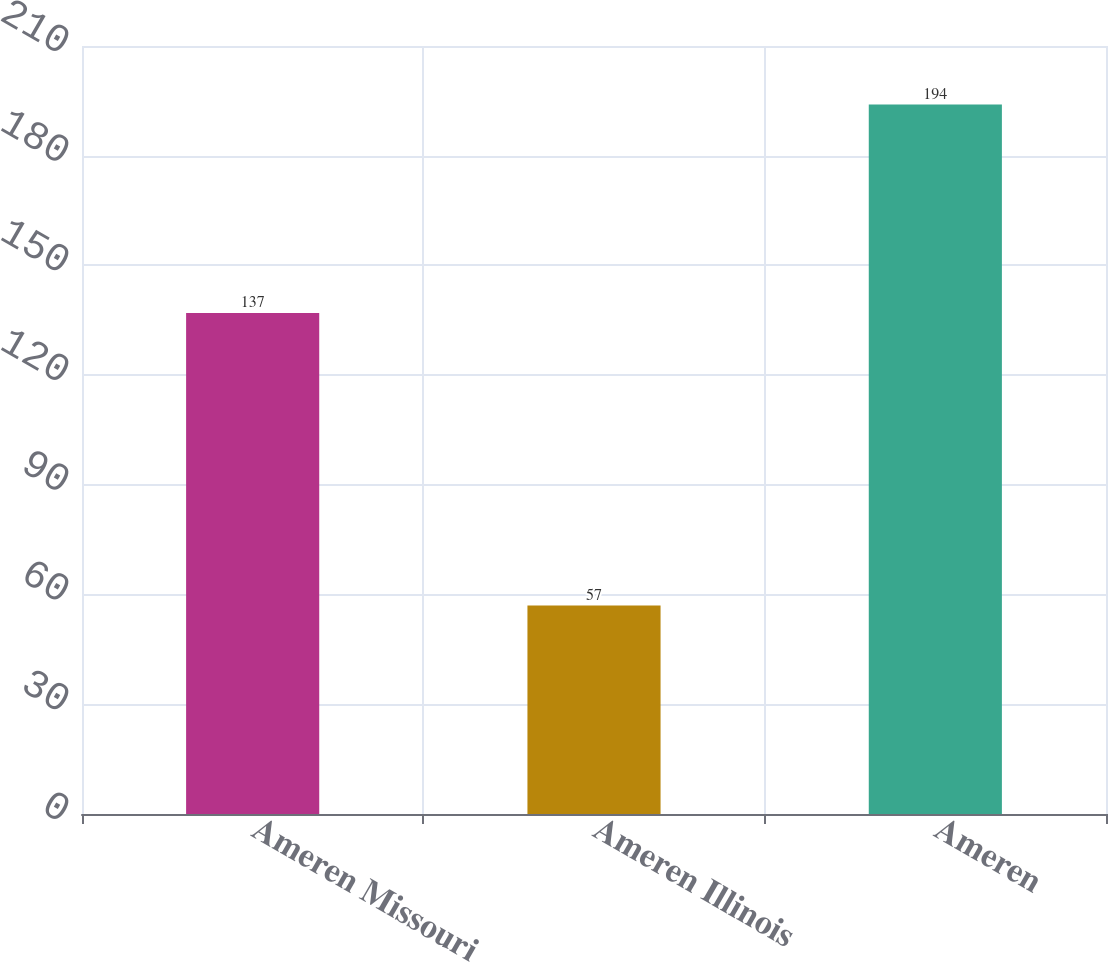<chart> <loc_0><loc_0><loc_500><loc_500><bar_chart><fcel>Ameren Missouri<fcel>Ameren Illinois<fcel>Ameren<nl><fcel>137<fcel>57<fcel>194<nl></chart> 